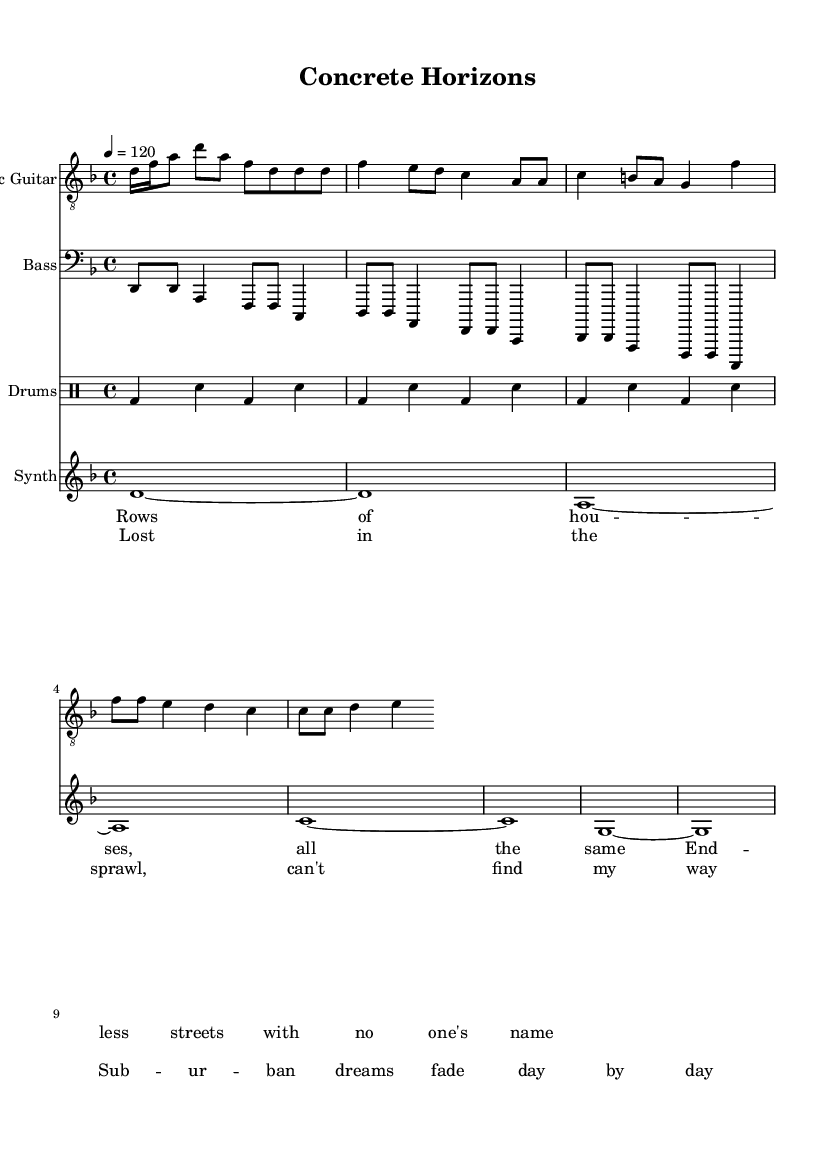What is the key signature of this music? The key signature shown in the music is D minor, which has one flat (B flat). This is indicated at the beginning of the score.
Answer: D minor What is the time signature of this music? The time signature is 4/4, which is displayed at the beginning of the sheet music. This means there are four beats per measure, and the quarter note receives one beat.
Answer: 4/4 What is the tempo of this piece? The tempo marking indicates that the piece should be played at a speed of 120 beats per minute. This is often noted by the '4 = 120' marking.
Answer: 120 How many measures are in the electric guitar part? Counting the measures in the electric guitar staff, there are a total of 8 measures. Each set of notes separated by vertical lines represents one measure.
Answer: 8 What is the lyrical theme presented in the verse? The verse lyrics describe the monotony of suburban life with "Rows of houses, all the same" indicating a lack of uniqueness in the environment.
Answer: Monotony What emotion does the chorus convey? The chorus expresses feelings of being lost and the fading of dreams, as shown by the lines "Lost in the sprawl, can't find my way" pointing to themes of alienation in suburbia.
Answer: Alienation What instruments are included in this score? The score includes an electric guitar, bass, drums, and synth, all specified at the beginning of each staff and drum part.
Answer: Electric guitar, bass, drums, synth 